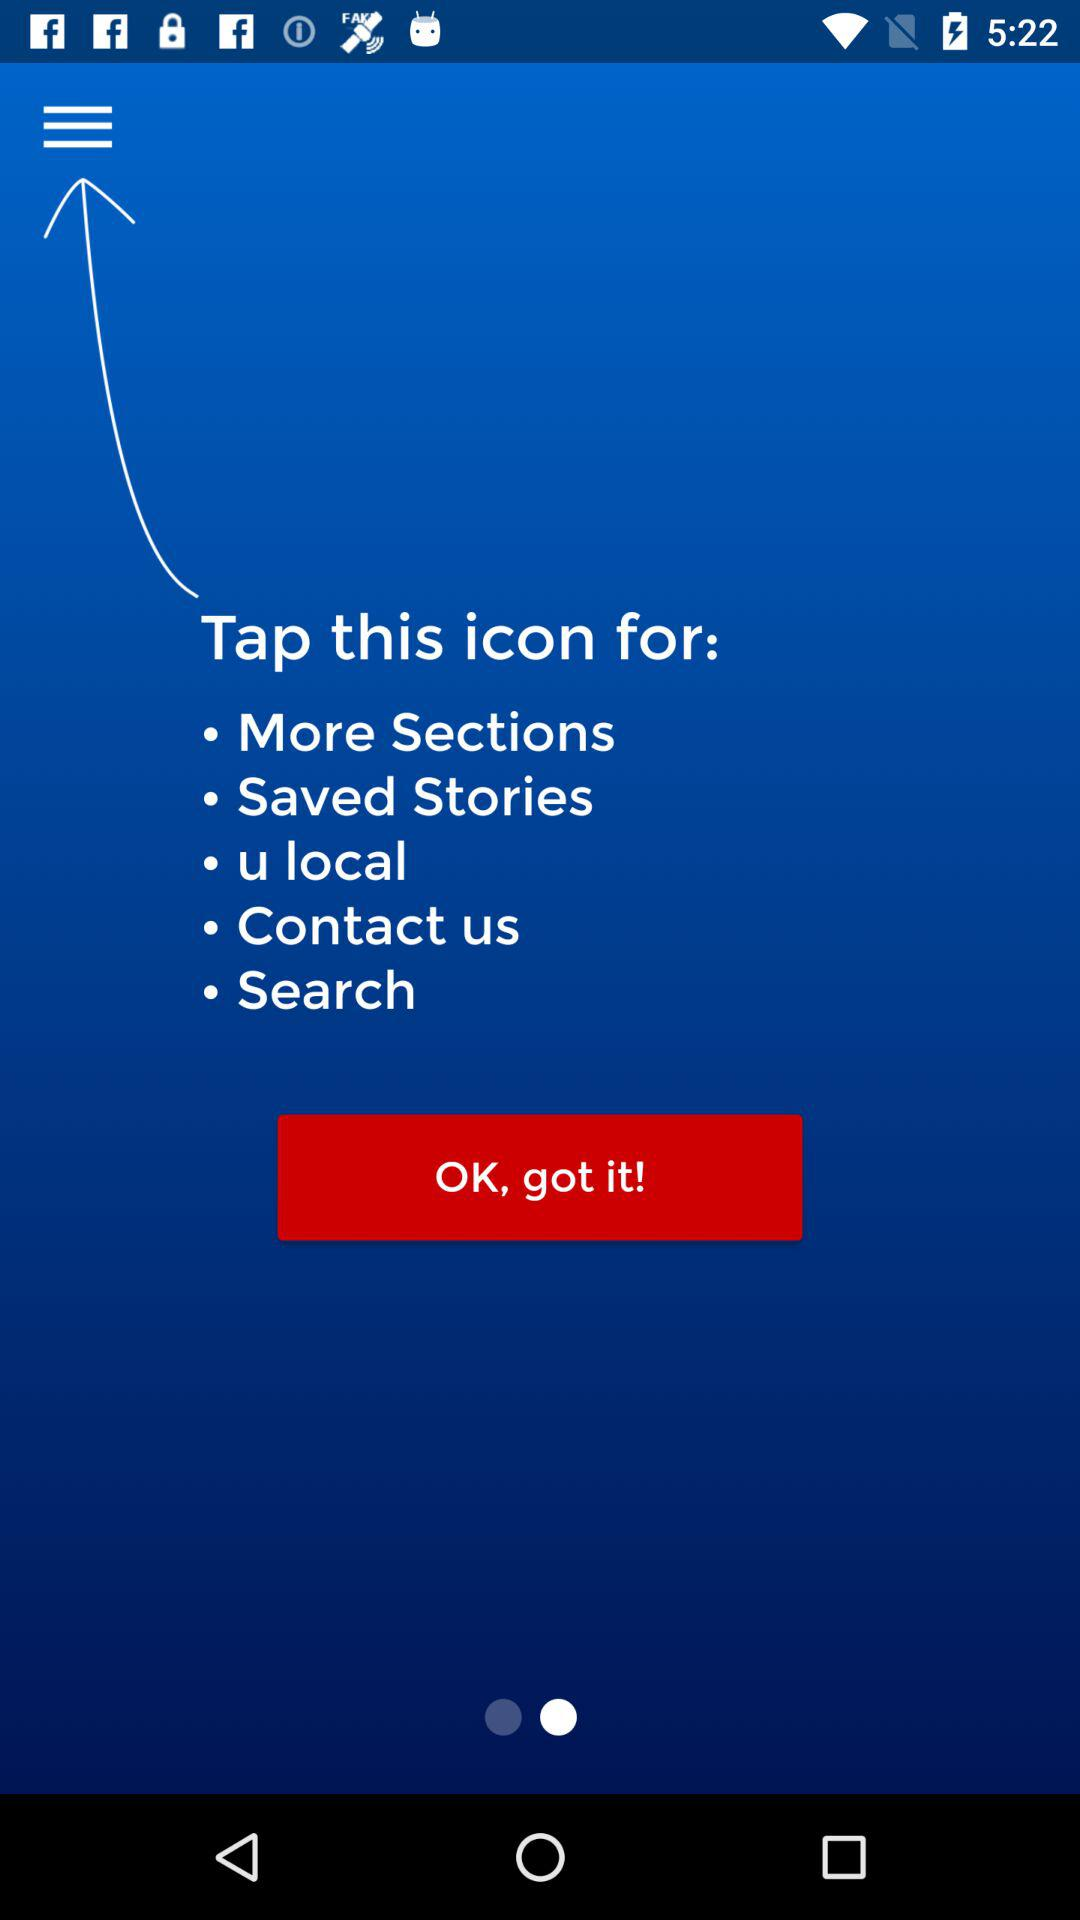How many sections are available in the menu?
Answer the question using a single word or phrase. 5 